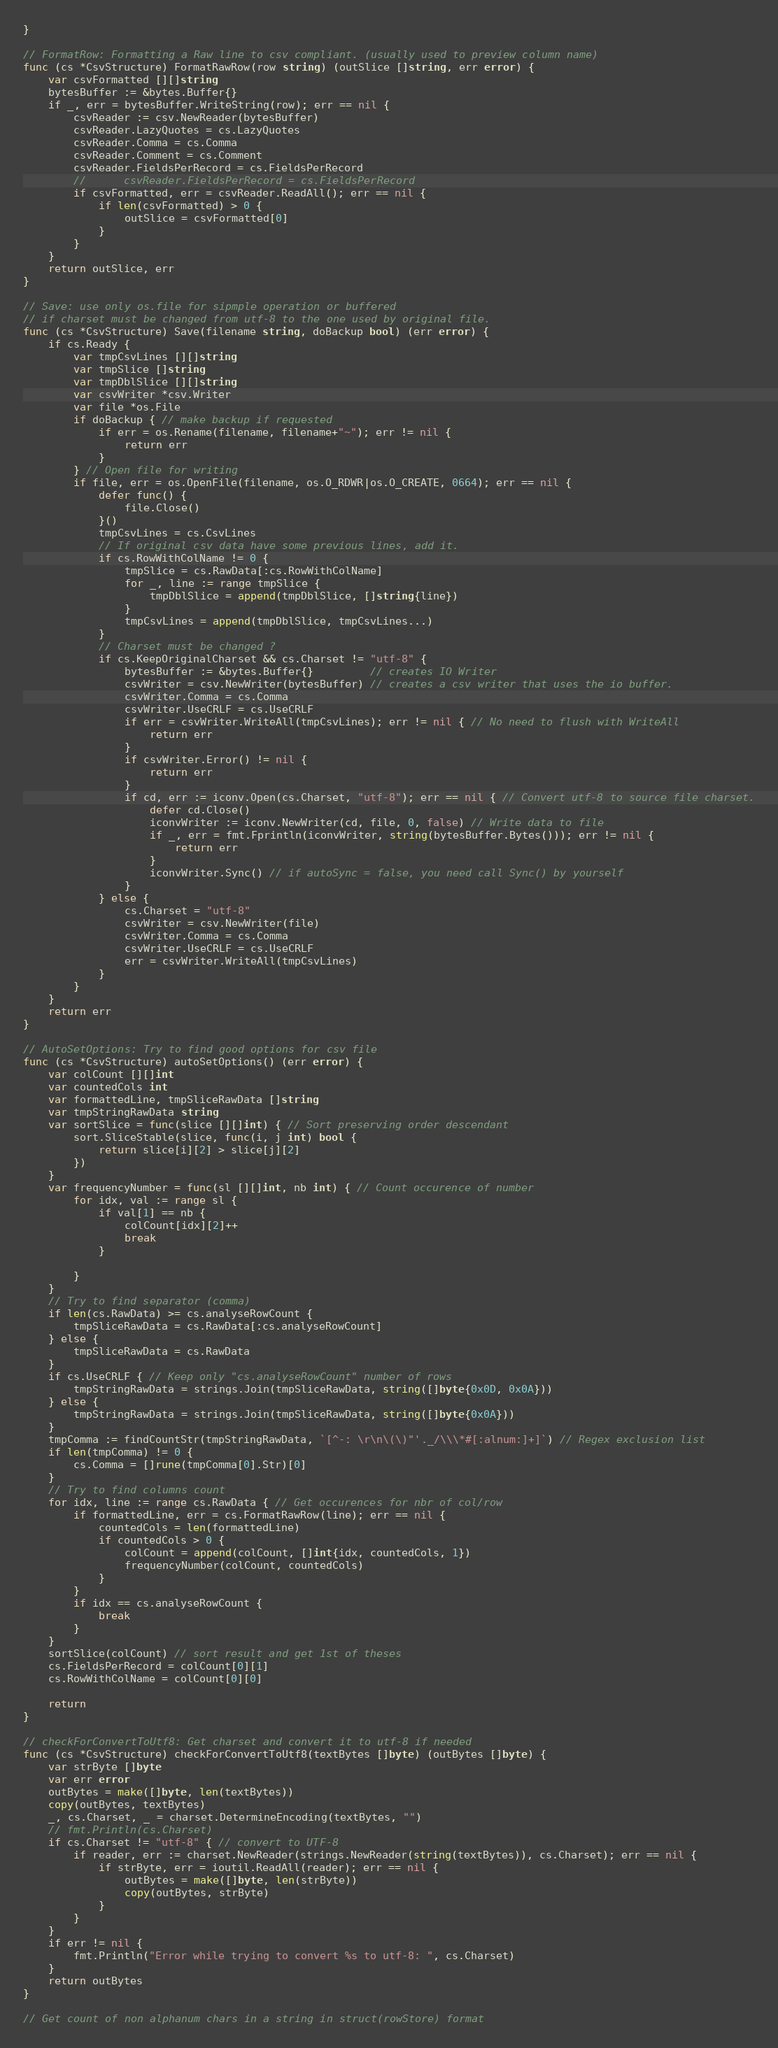Convert code to text. <code><loc_0><loc_0><loc_500><loc_500><_Go_>}

// FormatRow: Formatting a Raw line to csv compliant. (usually used to preview column name)
func (cs *CsvStructure) FormatRawRow(row string) (outSlice []string, err error) {
	var csvFormatted [][]string
	bytesBuffer := &bytes.Buffer{}
	if _, err = bytesBuffer.WriteString(row); err == nil {
		csvReader := csv.NewReader(bytesBuffer)
		csvReader.LazyQuotes = cs.LazyQuotes
		csvReader.Comma = cs.Comma
		csvReader.Comment = cs.Comment
		csvReader.FieldsPerRecord = cs.FieldsPerRecord
		//		csvReader.FieldsPerRecord = cs.FieldsPerRecord
		if csvFormatted, err = csvReader.ReadAll(); err == nil {
			if len(csvFormatted) > 0 {
				outSlice = csvFormatted[0]
			}
		}
	}
	return outSlice, err
}

// Save: use only os.file for sipmple operation or buffered
// if charset must be changed from utf-8 to the one used by original file.
func (cs *CsvStructure) Save(filename string, doBackup bool) (err error) {
	if cs.Ready {
		var tmpCsvLines [][]string
		var tmpSlice []string
		var tmpDblSlice [][]string
		var csvWriter *csv.Writer
		var file *os.File
		if doBackup { // make backup if requested
			if err = os.Rename(filename, filename+"~"); err != nil {
				return err
			}
		} // Open file for writing
		if file, err = os.OpenFile(filename, os.O_RDWR|os.O_CREATE, 0664); err == nil {
			defer func() {
				file.Close()
			}()
			tmpCsvLines = cs.CsvLines
			// If original csv data have some previous lines, add it.
			if cs.RowWithColName != 0 {
				tmpSlice = cs.RawData[:cs.RowWithColName]
				for _, line := range tmpSlice {
					tmpDblSlice = append(tmpDblSlice, []string{line})
				}
				tmpCsvLines = append(tmpDblSlice, tmpCsvLines...)
			}
			// Charset must be changed ?
			if cs.KeepOriginalCharset && cs.Charset != "utf-8" {
				bytesBuffer := &bytes.Buffer{}         // creates IO Writer
				csvWriter = csv.NewWriter(bytesBuffer) // creates a csv writer that uses the io buffer.
				csvWriter.Comma = cs.Comma
				csvWriter.UseCRLF = cs.UseCRLF
				if err = csvWriter.WriteAll(tmpCsvLines); err != nil { // No need to flush with WriteAll
					return err
				}
				if csvWriter.Error() != nil {
					return err
				}
				if cd, err := iconv.Open(cs.Charset, "utf-8"); err == nil { // Convert utf-8 to source file charset.
					defer cd.Close()
					iconvWriter := iconv.NewWriter(cd, file, 0, false) // Write data to file
					if _, err = fmt.Fprintln(iconvWriter, string(bytesBuffer.Bytes())); err != nil {
						return err
					}
					iconvWriter.Sync() // if autoSync = false, you need call Sync() by yourself
				}
			} else {
				cs.Charset = "utf-8"
				csvWriter = csv.NewWriter(file)
				csvWriter.Comma = cs.Comma
				csvWriter.UseCRLF = cs.UseCRLF
				err = csvWriter.WriteAll(tmpCsvLines)
			}
		}
	}
	return err
}

// AutoSetOptions: Try to find good options for csv file
func (cs *CsvStructure) autoSetOptions() (err error) {
	var colCount [][]int
	var countedCols int
	var formattedLine, tmpSliceRawData []string
	var tmpStringRawData string
	var sortSlice = func(slice [][]int) { // Sort preserving order descendant
		sort.SliceStable(slice, func(i, j int) bool {
			return slice[i][2] > slice[j][2]
		})
	}
	var frequencyNumber = func(sl [][]int, nb int) { // Count occurence of number
		for idx, val := range sl {
			if val[1] == nb {
				colCount[idx][2]++
				break
			}

		}
	}
	// Try to find separator (comma)
	if len(cs.RawData) >= cs.analyseRowCount {
		tmpSliceRawData = cs.RawData[:cs.analyseRowCount]
	} else {
		tmpSliceRawData = cs.RawData
	}
	if cs.UseCRLF { // Keep only "cs.analyseRowCount" number of rows
		tmpStringRawData = strings.Join(tmpSliceRawData, string([]byte{0x0D, 0x0A}))
	} else {
		tmpStringRawData = strings.Join(tmpSliceRawData, string([]byte{0x0A}))
	}
	tmpComma := findCountStr(tmpStringRawData, `[^-: \r\n\(\)"'._/\\\*#[:alnum:]+]`) // Regex exclusion list
	if len(tmpComma) != 0 {
		cs.Comma = []rune(tmpComma[0].Str)[0]
	}
	// Try to find columns count
	for idx, line := range cs.RawData { // Get occurences for nbr of col/row
		if formattedLine, err = cs.FormatRawRow(line); err == nil {
			countedCols = len(formattedLine)
			if countedCols > 0 {
				colCount = append(colCount, []int{idx, countedCols, 1})
				frequencyNumber(colCount, countedCols)
			}
		}
		if idx == cs.analyseRowCount {
			break
		}
	}
	sortSlice(colCount) // sort result and get 1st of theses
	cs.FieldsPerRecord = colCount[0][1]
	cs.RowWithColName = colCount[0][0]

	return
}

// checkForConvertToUtf8: Get charset and convert it to utf-8 if needed
func (cs *CsvStructure) checkForConvertToUtf8(textBytes []byte) (outBytes []byte) {
	var strByte []byte
	var err error
	outBytes = make([]byte, len(textBytes))
	copy(outBytes, textBytes)
	_, cs.Charset, _ = charset.DetermineEncoding(textBytes, "")
	// fmt.Println(cs.Charset)
	if cs.Charset != "utf-8" { // convert to UTF-8
		if reader, err := charset.NewReader(strings.NewReader(string(textBytes)), cs.Charset); err == nil {
			if strByte, err = ioutil.ReadAll(reader); err == nil {
				outBytes = make([]byte, len(strByte))
				copy(outBytes, strByte)
			}
		}
	}
	if err != nil {
		fmt.Println("Error while trying to convert %s to utf-8: ", cs.Charset)
	}
	return outBytes
}

// Get count of non alphanum chars in a string in struct(rowStore) format</code> 